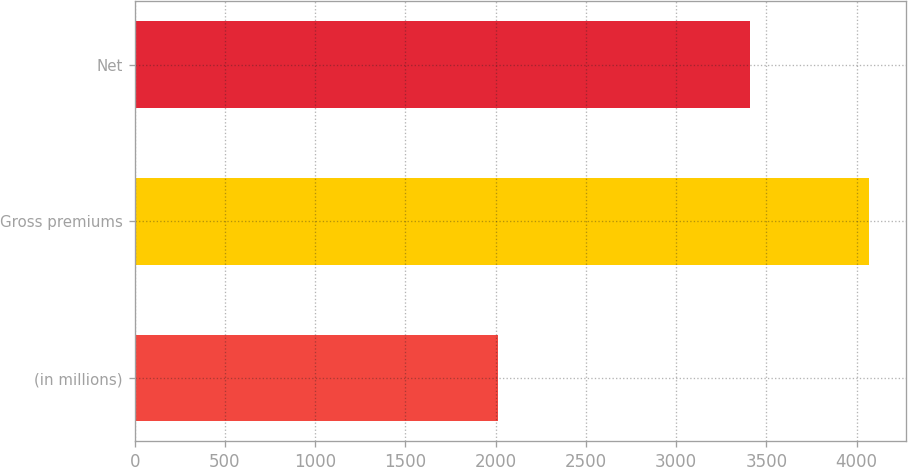Convert chart to OTSL. <chart><loc_0><loc_0><loc_500><loc_500><bar_chart><fcel>(in millions)<fcel>Gross premiums<fcel>Net<nl><fcel>2014<fcel>4070<fcel>3409<nl></chart> 